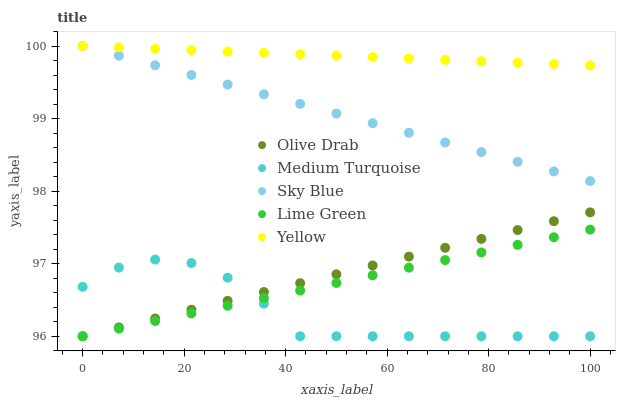Does Medium Turquoise have the minimum area under the curve?
Answer yes or no. Yes. Does Yellow have the maximum area under the curve?
Answer yes or no. Yes. Does Lime Green have the minimum area under the curve?
Answer yes or no. No. Does Lime Green have the maximum area under the curve?
Answer yes or no. No. Is Olive Drab the smoothest?
Answer yes or no. Yes. Is Medium Turquoise the roughest?
Answer yes or no. Yes. Is Yellow the smoothest?
Answer yes or no. No. Is Yellow the roughest?
Answer yes or no. No. Does Lime Green have the lowest value?
Answer yes or no. Yes. Does Yellow have the lowest value?
Answer yes or no. No. Does Yellow have the highest value?
Answer yes or no. Yes. Does Lime Green have the highest value?
Answer yes or no. No. Is Olive Drab less than Sky Blue?
Answer yes or no. Yes. Is Yellow greater than Medium Turquoise?
Answer yes or no. Yes. Does Lime Green intersect Medium Turquoise?
Answer yes or no. Yes. Is Lime Green less than Medium Turquoise?
Answer yes or no. No. Is Lime Green greater than Medium Turquoise?
Answer yes or no. No. Does Olive Drab intersect Sky Blue?
Answer yes or no. No. 